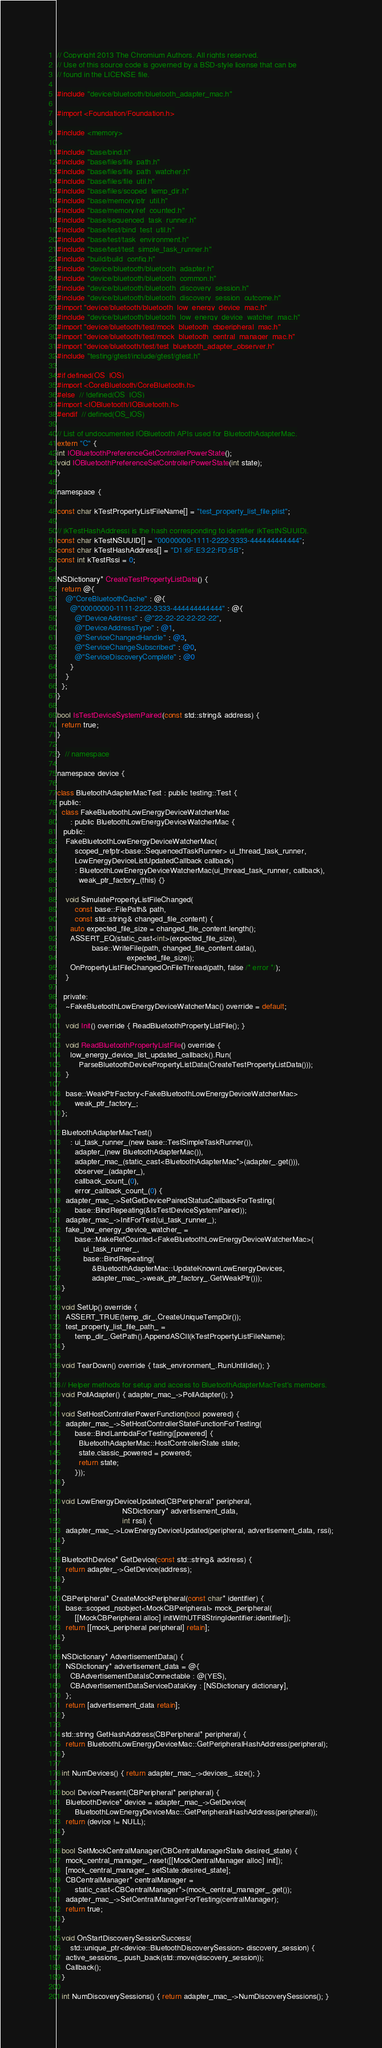<code> <loc_0><loc_0><loc_500><loc_500><_ObjectiveC_>// Copyright 2013 The Chromium Authors. All rights reserved.
// Use of this source code is governed by a BSD-style license that can be
// found in the LICENSE file.

#include "device/bluetooth/bluetooth_adapter_mac.h"

#import <Foundation/Foundation.h>

#include <memory>

#include "base/bind.h"
#include "base/files/file_path.h"
#include "base/files/file_path_watcher.h"
#include "base/files/file_util.h"
#include "base/files/scoped_temp_dir.h"
#include "base/memory/ptr_util.h"
#include "base/memory/ref_counted.h"
#include "base/sequenced_task_runner.h"
#include "base/test/bind_test_util.h"
#include "base/test/task_environment.h"
#include "base/test/test_simple_task_runner.h"
#include "build/build_config.h"
#include "device/bluetooth/bluetooth_adapter.h"
#include "device/bluetooth/bluetooth_common.h"
#include "device/bluetooth/bluetooth_discovery_session.h"
#include "device/bluetooth/bluetooth_discovery_session_outcome.h"
#import "device/bluetooth/bluetooth_low_energy_device_mac.h"
#include "device/bluetooth/bluetooth_low_energy_device_watcher_mac.h"
#import "device/bluetooth/test/mock_bluetooth_cbperipheral_mac.h"
#import "device/bluetooth/test/mock_bluetooth_central_manager_mac.h"
#import "device/bluetooth/test/test_bluetooth_adapter_observer.h"
#include "testing/gtest/include/gtest/gtest.h"

#if defined(OS_IOS)
#import <CoreBluetooth/CoreBluetooth.h>
#else  // !defined(OS_IOS)
#import <IOBluetooth/IOBluetooth.h>
#endif  // defined(OS_IOS)

// List of undocumented IOBluetooth APIs used for BluetoothAdapterMac.
extern "C" {
int IOBluetoothPreferenceGetControllerPowerState();
void IOBluetoothPreferenceSetControllerPowerState(int state);
}

namespace {

const char kTestPropertyListFileName[] = "test_property_list_file.plist";

// |kTestHashAddress| is the hash corresponding to identifier |kTestNSUUID|.
const char kTestNSUUID[] = "00000000-1111-2222-3333-444444444444";
const char kTestHashAddress[] = "D1:6F:E3:22:FD:5B";
const int kTestRssi = 0;

NSDictionary* CreateTestPropertyListData() {
  return @{
    @"CoreBluetoothCache" : @{
      @"00000000-1111-2222-3333-444444444444" : @{
        @"DeviceAddress" : @"22-22-22-22-22-22",
        @"DeviceAddressType" : @1,
        @"ServiceChangedHandle" : @3,
        @"ServiceChangeSubscribed" : @0,
        @"ServiceDiscoveryComplete" : @0
      }
    }
  };
}

bool IsTestDeviceSystemPaired(const std::string& address) {
  return true;
}

}  // namespace

namespace device {

class BluetoothAdapterMacTest : public testing::Test {
 public:
  class FakeBluetoothLowEnergyDeviceWatcherMac
      : public BluetoothLowEnergyDeviceWatcherMac {
   public:
    FakeBluetoothLowEnergyDeviceWatcherMac(
        scoped_refptr<base::SequencedTaskRunner> ui_thread_task_runner,
        LowEnergyDeviceListUpdatedCallback callback)
        : BluetoothLowEnergyDeviceWatcherMac(ui_thread_task_runner, callback),
          weak_ptr_factory_(this) {}

    void SimulatePropertyListFileChanged(
        const base::FilePath& path,
        const std::string& changed_file_content) {
      auto expected_file_size = changed_file_content.length();
      ASSERT_EQ(static_cast<int>(expected_file_size),
                base::WriteFile(path, changed_file_content.data(),
                                expected_file_size));
      OnPropertyListFileChangedOnFileThread(path, false /* error */);
    }

   private:
    ~FakeBluetoothLowEnergyDeviceWatcherMac() override = default;

    void Init() override { ReadBluetoothPropertyListFile(); }

    void ReadBluetoothPropertyListFile() override {
      low_energy_device_list_updated_callback().Run(
          ParseBluetoothDevicePropertyListData(CreateTestPropertyListData()));
    }

    base::WeakPtrFactory<FakeBluetoothLowEnergyDeviceWatcherMac>
        weak_ptr_factory_;
  };

  BluetoothAdapterMacTest()
      : ui_task_runner_(new base::TestSimpleTaskRunner()),
        adapter_(new BluetoothAdapterMac()),
        adapter_mac_(static_cast<BluetoothAdapterMac*>(adapter_.get())),
        observer_(adapter_),
        callback_count_(0),
        error_callback_count_(0) {
    adapter_mac_->SetGetDevicePairedStatusCallbackForTesting(
        base::BindRepeating(&IsTestDeviceSystemPaired));
    adapter_mac_->InitForTest(ui_task_runner_);
    fake_low_energy_device_watcher_ =
        base::MakeRefCounted<FakeBluetoothLowEnergyDeviceWatcherMac>(
            ui_task_runner_,
            base::BindRepeating(
                &BluetoothAdapterMac::UpdateKnownLowEnergyDevices,
                adapter_mac_->weak_ptr_factory_.GetWeakPtr()));
  }

  void SetUp() override {
    ASSERT_TRUE(temp_dir_.CreateUniqueTempDir());
    test_property_list_file_path_ =
        temp_dir_.GetPath().AppendASCII(kTestPropertyListFileName);
  }

  void TearDown() override { task_environment_.RunUntilIdle(); }

  // Helper methods for setup and access to BluetoothAdapterMacTest's members.
  void PollAdapter() { adapter_mac_->PollAdapter(); }

  void SetHostControllerPowerFunction(bool powered) {
    adapter_mac_->SetHostControllerStateFunctionForTesting(
        base::BindLambdaForTesting([powered] {
          BluetoothAdapterMac::HostControllerState state;
          state.classic_powered = powered;
          return state;
        }));
  }

  void LowEnergyDeviceUpdated(CBPeripheral* peripheral,
                              NSDictionary* advertisement_data,
                              int rssi) {
    adapter_mac_->LowEnergyDeviceUpdated(peripheral, advertisement_data, rssi);
  }

  BluetoothDevice* GetDevice(const std::string& address) {
    return adapter_->GetDevice(address);
  }

  CBPeripheral* CreateMockPeripheral(const char* identifier) {
    base::scoped_nsobject<MockCBPeripheral> mock_peripheral(
        [[MockCBPeripheral alloc] initWithUTF8StringIdentifier:identifier]);
    return [[mock_peripheral peripheral] retain];
  }

  NSDictionary* AdvertisementData() {
    NSDictionary* advertisement_data = @{
      CBAdvertisementDataIsConnectable : @(YES),
      CBAdvertisementDataServiceDataKey : [NSDictionary dictionary],
    };
    return [advertisement_data retain];
  }

  std::string GetHashAddress(CBPeripheral* peripheral) {
    return BluetoothLowEnergyDeviceMac::GetPeripheralHashAddress(peripheral);
  }

  int NumDevices() { return adapter_mac_->devices_.size(); }

  bool DevicePresent(CBPeripheral* peripheral) {
    BluetoothDevice* device = adapter_mac_->GetDevice(
        BluetoothLowEnergyDeviceMac::GetPeripheralHashAddress(peripheral));
    return (device != NULL);
  }

  bool SetMockCentralManager(CBCentralManagerState desired_state) {
    mock_central_manager_.reset([[MockCentralManager alloc] init]);
    [mock_central_manager_ setState:desired_state];
    CBCentralManager* centralManager =
        static_cast<CBCentralManager*>(mock_central_manager_.get());
    adapter_mac_->SetCentralManagerForTesting(centralManager);
    return true;
  }

  void OnStartDiscoverySessionSuccess(
      std::unique_ptr<device::BluetoothDiscoverySession> discovery_session) {
    active_sessions_.push_back(std::move(discovery_session));
    Callback();
  }

  int NumDiscoverySessions() { return adapter_mac_->NumDiscoverySessions(); }
</code> 